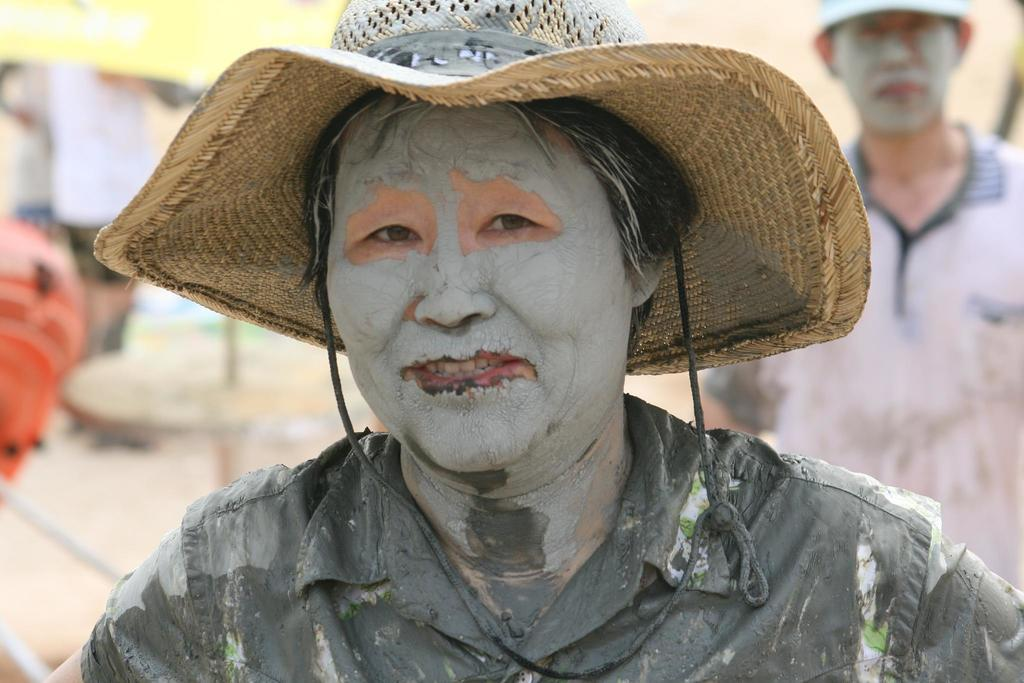Who is the main subject in the center of the image? There is a man in the center of the image. What is the man in the center wearing? The man in the center is wearing a hat. Can you describe the other person in the image? There is another man on the right side of the image. What type of flock can be seen flying in the background of the image? There is no flock visible in the image; it only features two men. 